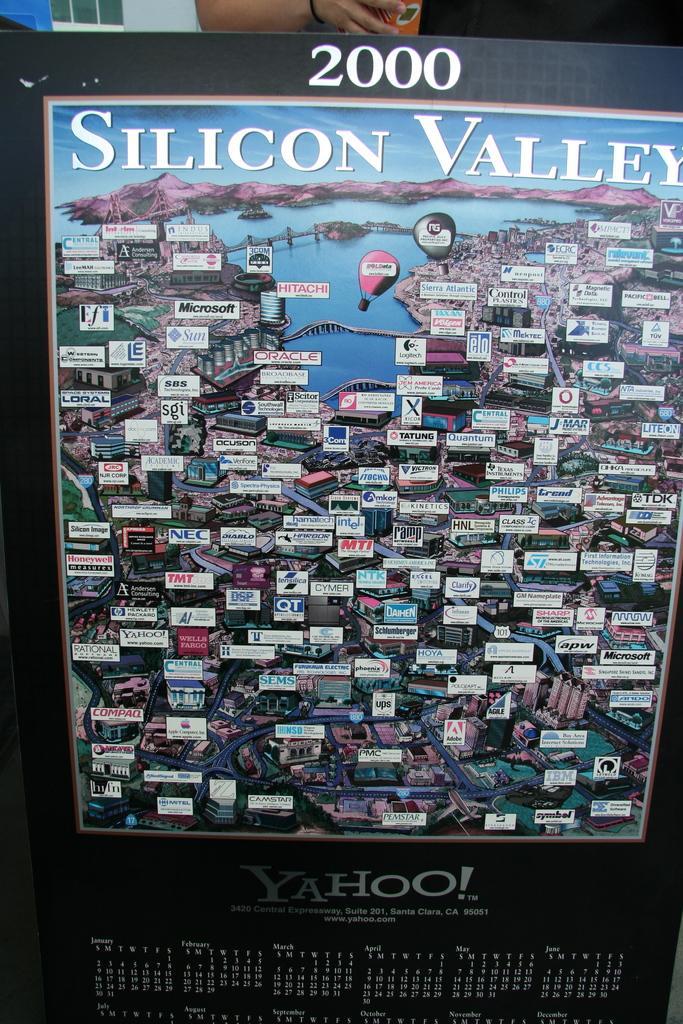Describe this image in one or two sentences. In this image I can see a black colored board on which I can see the image of a city in which I can see few roads, few buildings, few trees, few air balloons, a bridge and the water. I can see few mountains and the sky. At the top of the image I can see a person's hand. 